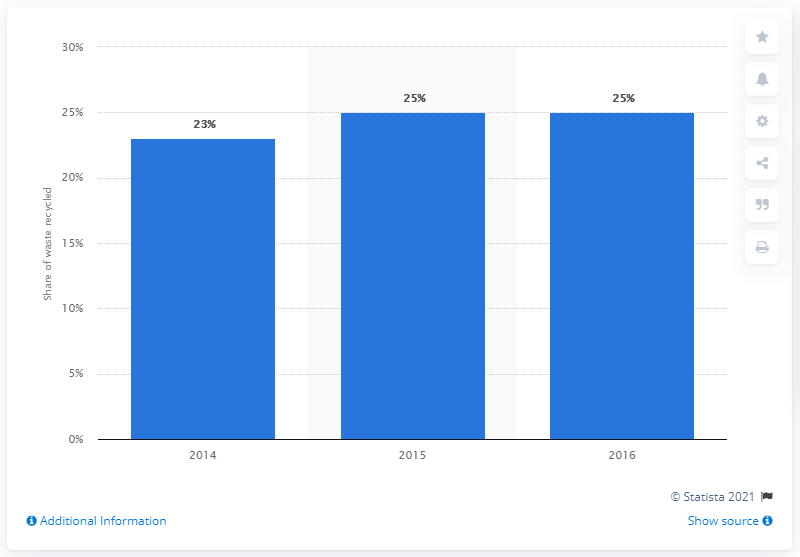Specify some key components in this picture. The previous year's percentage of waste recycled in McDonald's restaurants was 23%. 